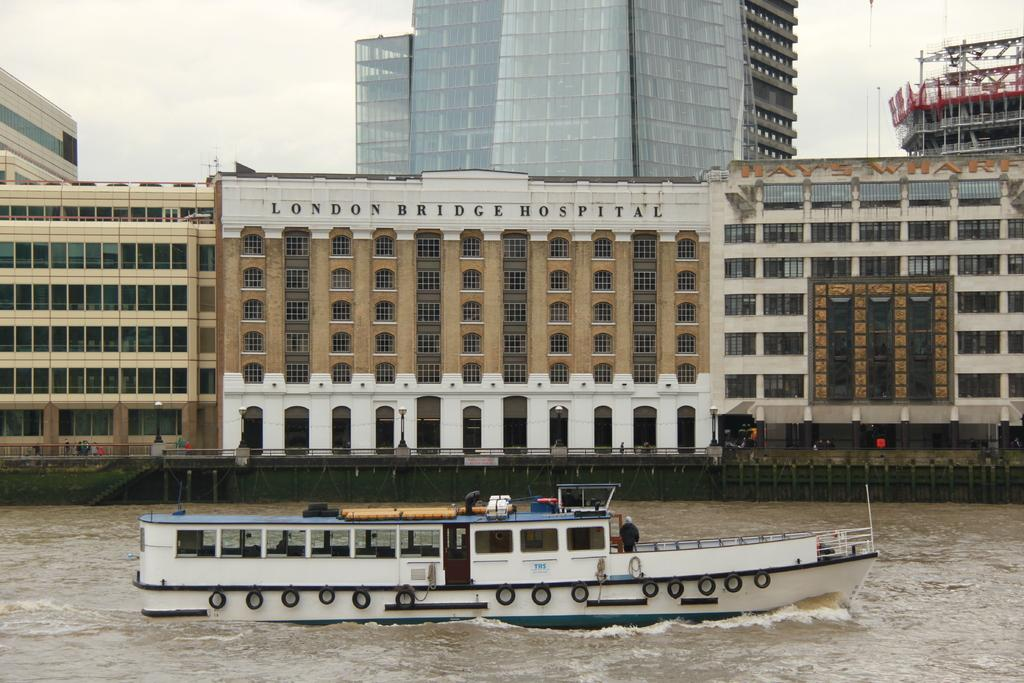<image>
Share a concise interpretation of the image provided. A boat is on the river in front of the London Bridge Hospital. 